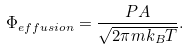<formula> <loc_0><loc_0><loc_500><loc_500>\Phi _ { e f f u s i o n } = { \frac { P A } { \sqrt { 2 \pi m k _ { B } T } } } .</formula> 